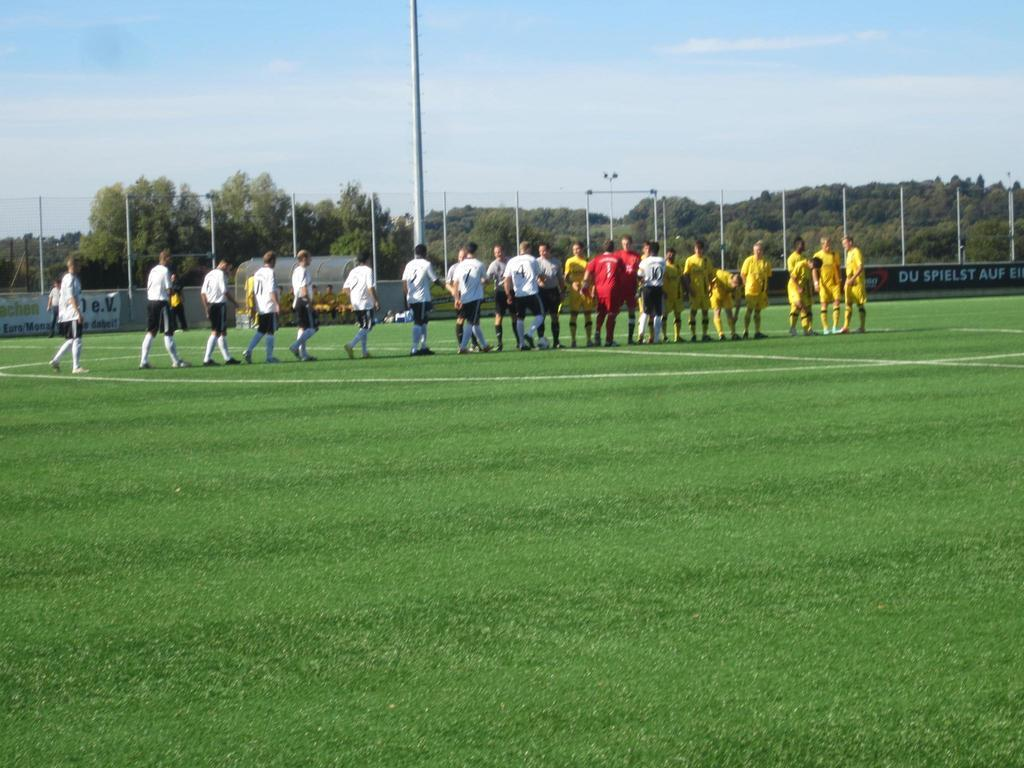What is happening in the image? There are players in the image, and they are walking on a ground. What colors are the players' dresses? Some players are wearing white color dresses, and some are wearing yellow color dresses. What can be seen in the background of the image? There are green trees visible in the background of the image. What type of orange is being used by the players in the image? There is no orange present in the image; the players are wearing white and yellow dresses. What do the players need to win the game in the image? The image does not provide information about a game or the players' need to win, so we cannot determine what they might need. 